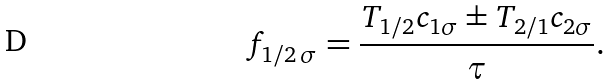<formula> <loc_0><loc_0><loc_500><loc_500>f _ { 1 / 2 \, \sigma } = \frac { T _ { 1 / 2 } c _ { 1 \sigma } \pm T _ { 2 / 1 } c _ { 2 \sigma } } { \tau } .</formula> 